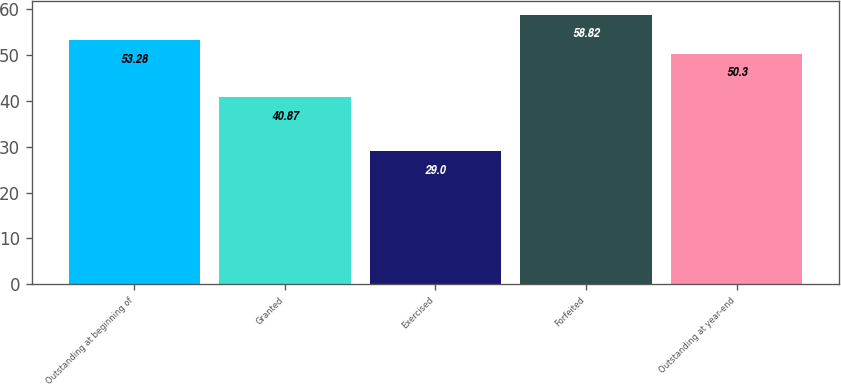<chart> <loc_0><loc_0><loc_500><loc_500><bar_chart><fcel>Outstanding at beginning of<fcel>Granted<fcel>Exercised<fcel>Forfeited<fcel>Outstanding at year-end<nl><fcel>53.28<fcel>40.87<fcel>29<fcel>58.82<fcel>50.3<nl></chart> 